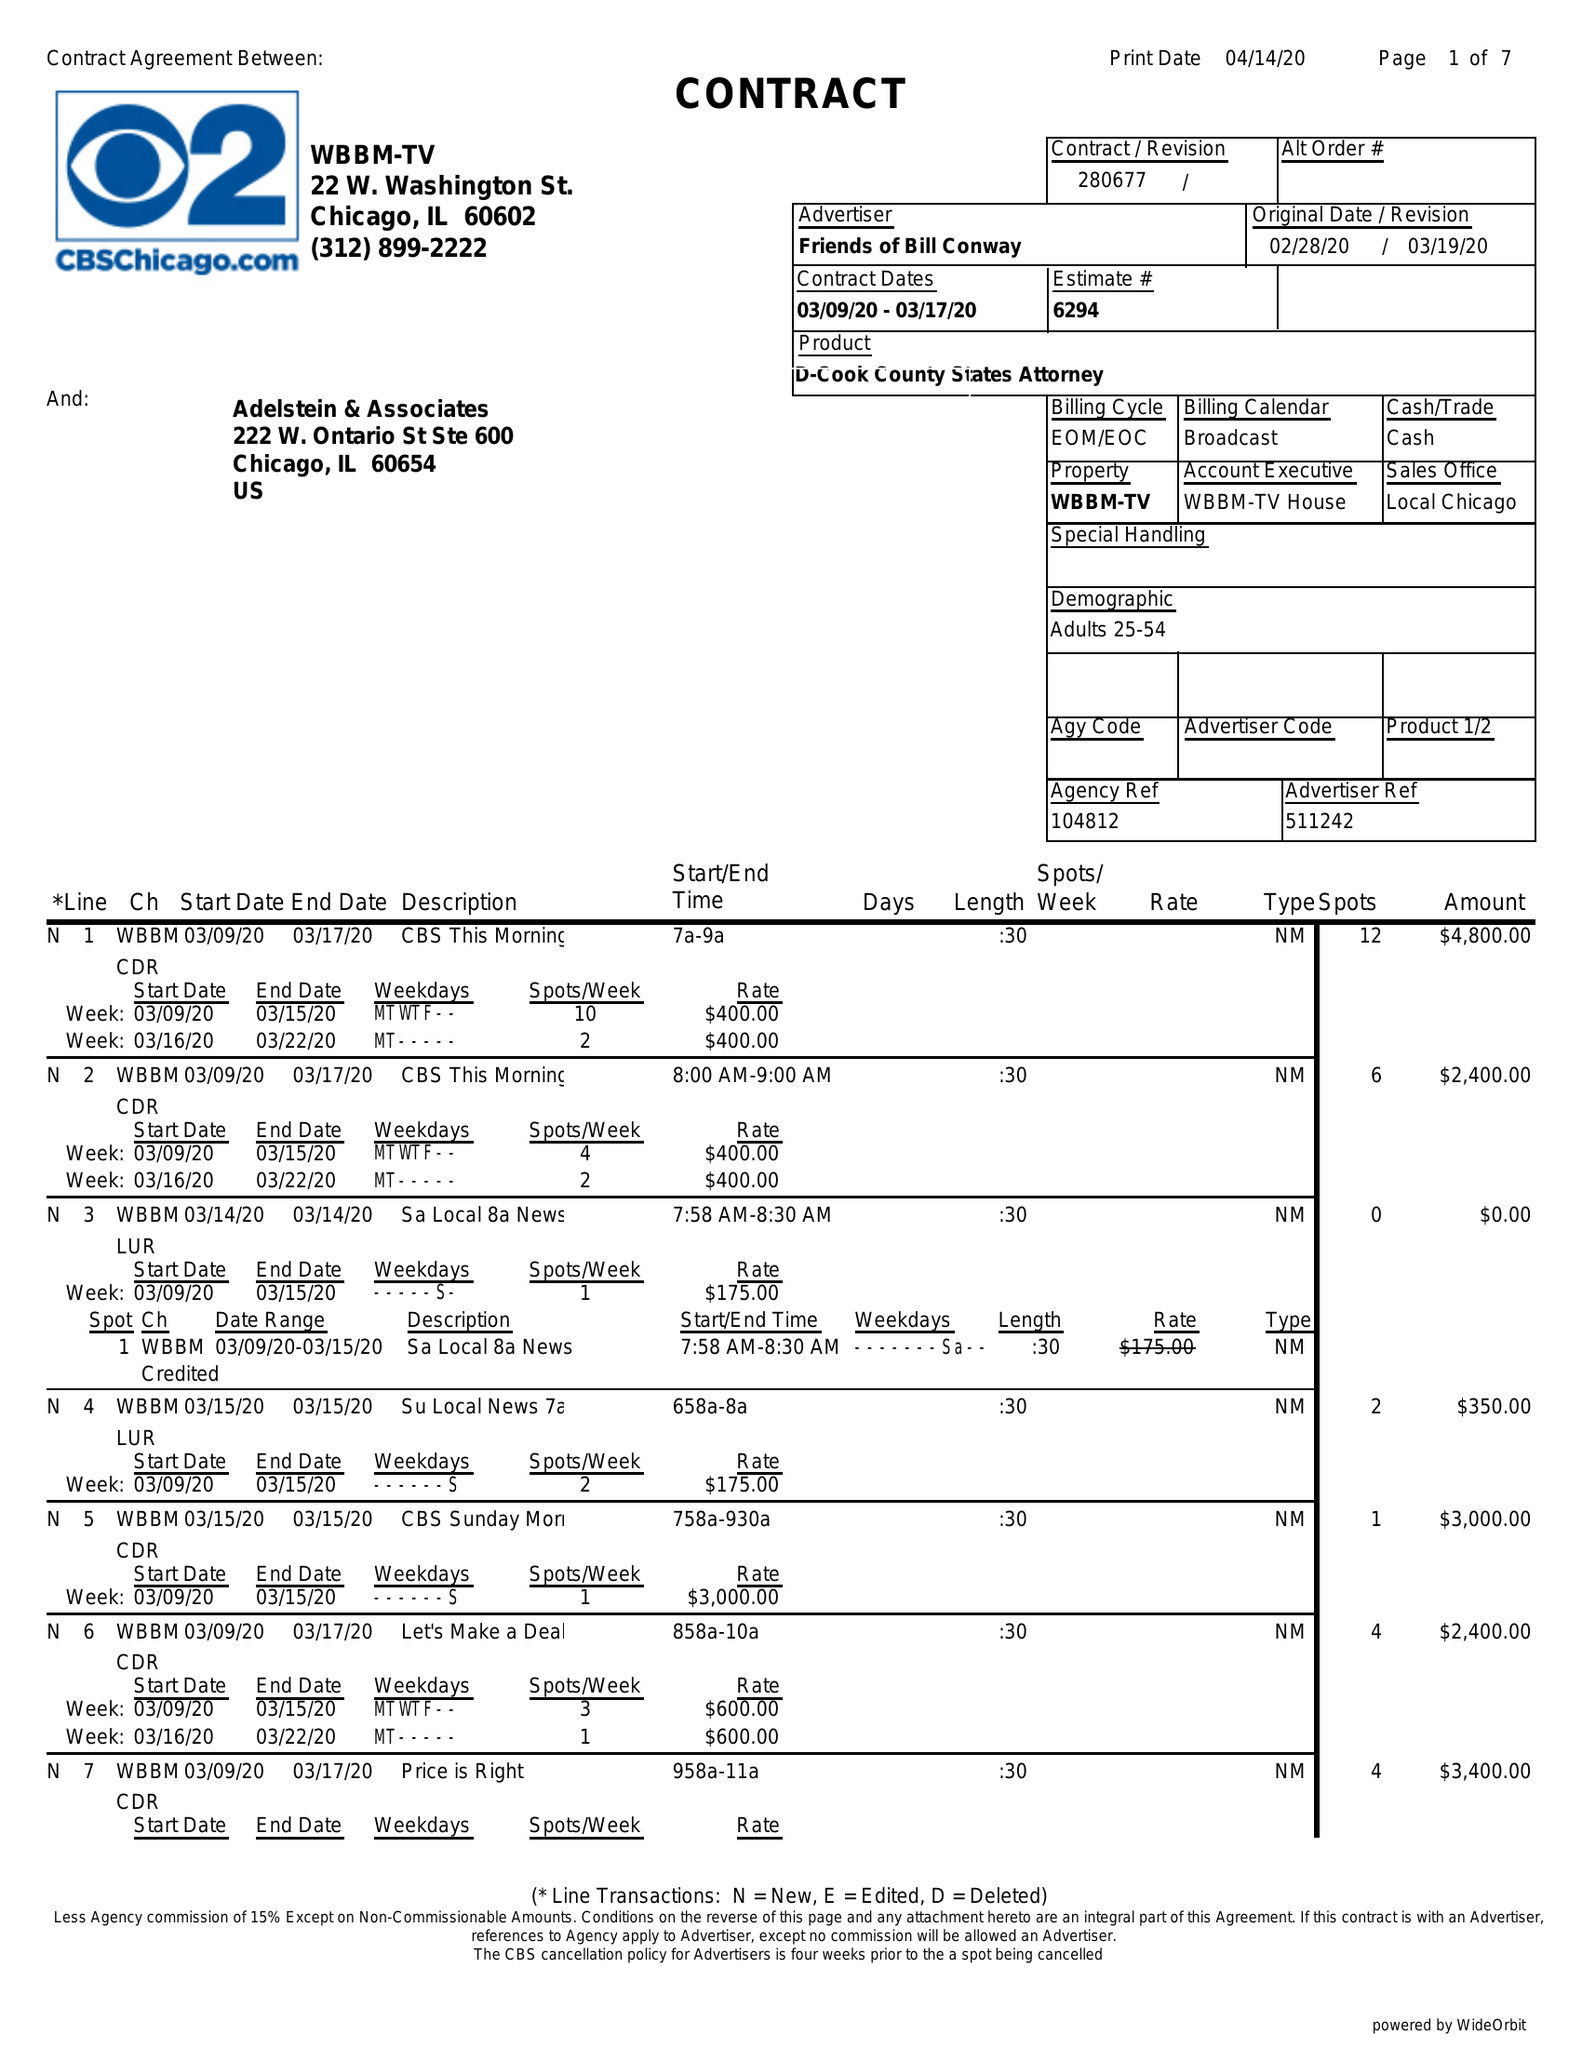What is the value for the flight_to?
Answer the question using a single word or phrase. 03/17/20 